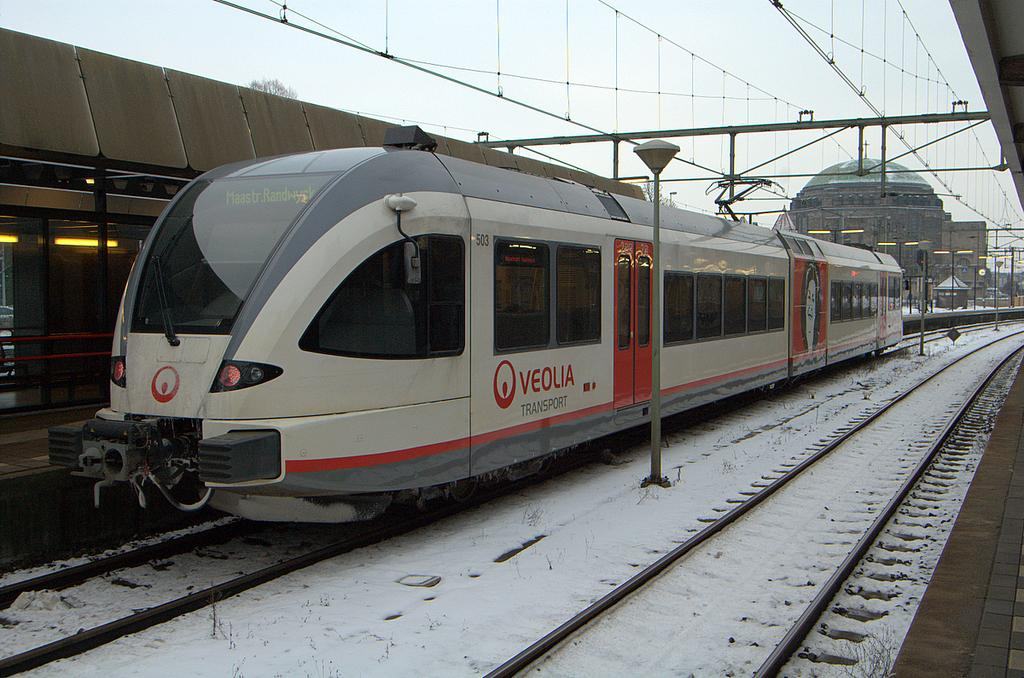What is the main subject in the middle of the image? There is a train in the middle of the image. What structure can be seen at the top of the image? There is a building at the top of the image. What type of location might the image depict? The image appears to depict a railway station. Reasoning: Let' Let's think step by step in order to produce the conversation. We start by identifying the main subject in the image, which is the train. Then, we expand the conversation to include other structures or elements that are also visible, such as the building. Finally, we make an educated guess about the location based on the presence of the train and the building, suggesting that it might be a railway station. Absurd Question/Answer: What type of stove can be seen in the image? There is no stove present in the image. How does the brain of the train function in the image? Trains do not have brains; they are inanimate objects powered by engines. 